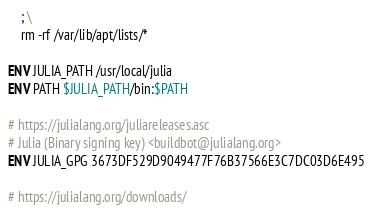<code> <loc_0><loc_0><loc_500><loc_500><_Dockerfile_>	; \
	rm -rf /var/lib/apt/lists/*

ENV JULIA_PATH /usr/local/julia
ENV PATH $JULIA_PATH/bin:$PATH

# https://julialang.org/juliareleases.asc
# Julia (Binary signing key) <buildbot@julialang.org>
ENV JULIA_GPG 3673DF529D9049477F76B37566E3C7DC03D6E495

# https://julialang.org/downloads/</code> 